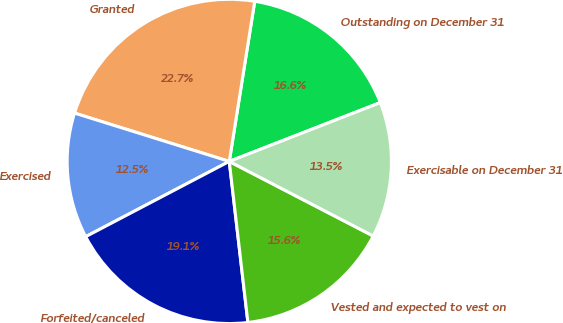Convert chart to OTSL. <chart><loc_0><loc_0><loc_500><loc_500><pie_chart><fcel>Outstanding on December 31<fcel>Granted<fcel>Exercised<fcel>Forfeited/canceled<fcel>Vested and expected to vest on<fcel>Exercisable on December 31<nl><fcel>16.58%<fcel>22.69%<fcel>12.5%<fcel>19.15%<fcel>15.56%<fcel>13.52%<nl></chart> 